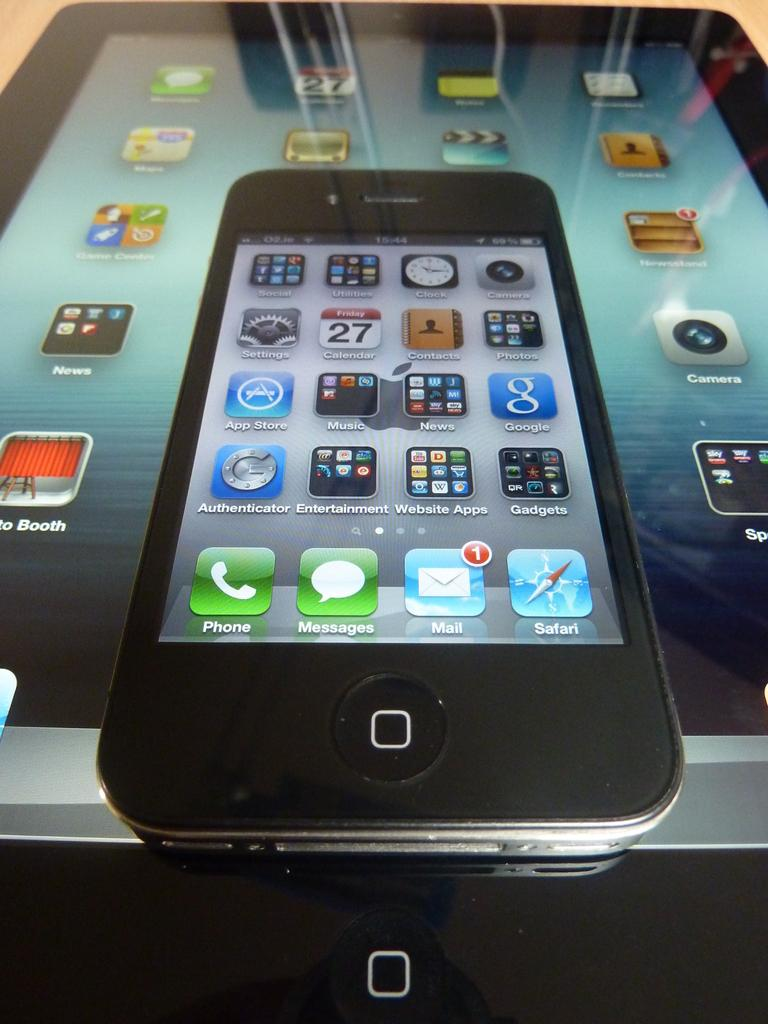<image>
Offer a succinct explanation of the picture presented. an iPhone with icons reading Phone and MAIL sits on an iPad 